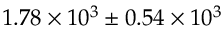Convert formula to latex. <formula><loc_0><loc_0><loc_500><loc_500>1 . 7 8 \times 1 0 ^ { 3 } \pm { 0 . 5 4 \times 1 0 ^ { 3 } }</formula> 